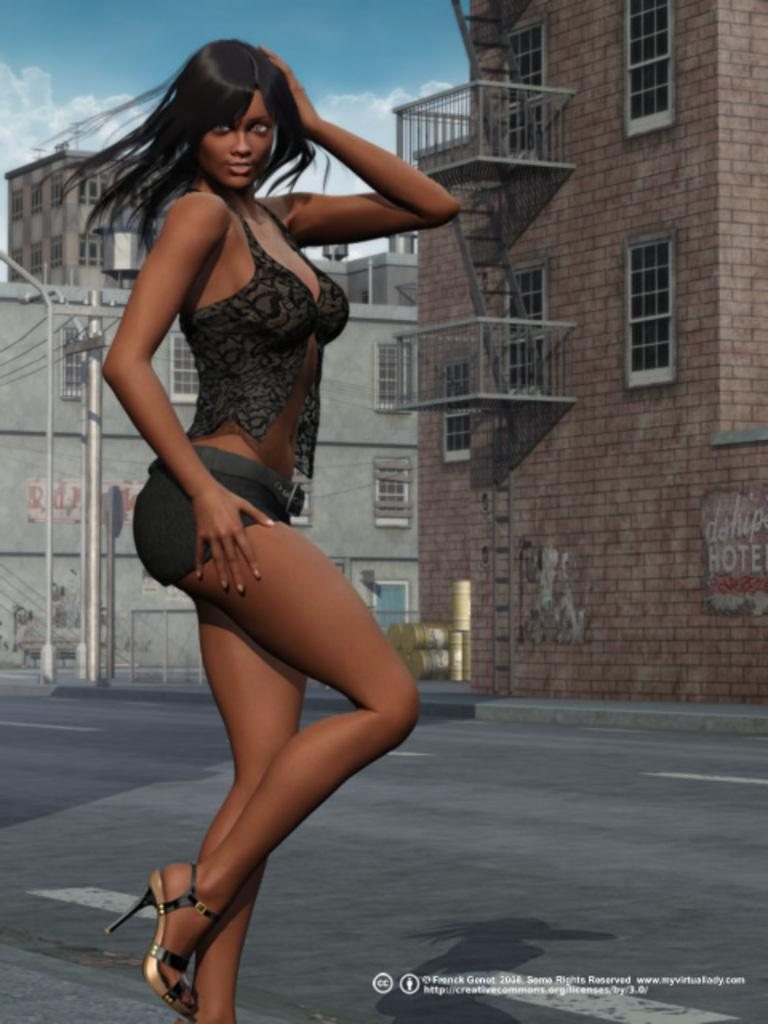What is the main subject in the image? There is a woman standing in the image. What type of structures can be seen in the background? There are buildings with windows in the image. What other objects are present in the image? There are poles and barrels in the image. Is there any additional information about the image itself? Yes, there is a watermark on the image. How many horses are present in the image? There are no horses present in the image. Is there a gate visible in the image? There is no gate visible in the image. 